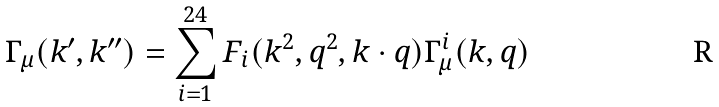Convert formula to latex. <formula><loc_0><loc_0><loc_500><loc_500>\Gamma _ { \mu } ( k ^ { \prime } , k ^ { \prime \prime } ) = \sum _ { i = 1 } ^ { 2 4 } F _ { i } ( k ^ { 2 } , q ^ { 2 } , k \cdot q ) \Gamma _ { \mu } ^ { i } ( k , q )</formula> 